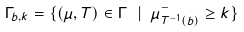Convert formula to latex. <formula><loc_0><loc_0><loc_500><loc_500>\Gamma _ { b , k } = \{ ( \mu , T ) \in \Gamma \ | \ \mu ^ { - } _ { T ^ { - 1 } ( b ) } \geq k \}</formula> 